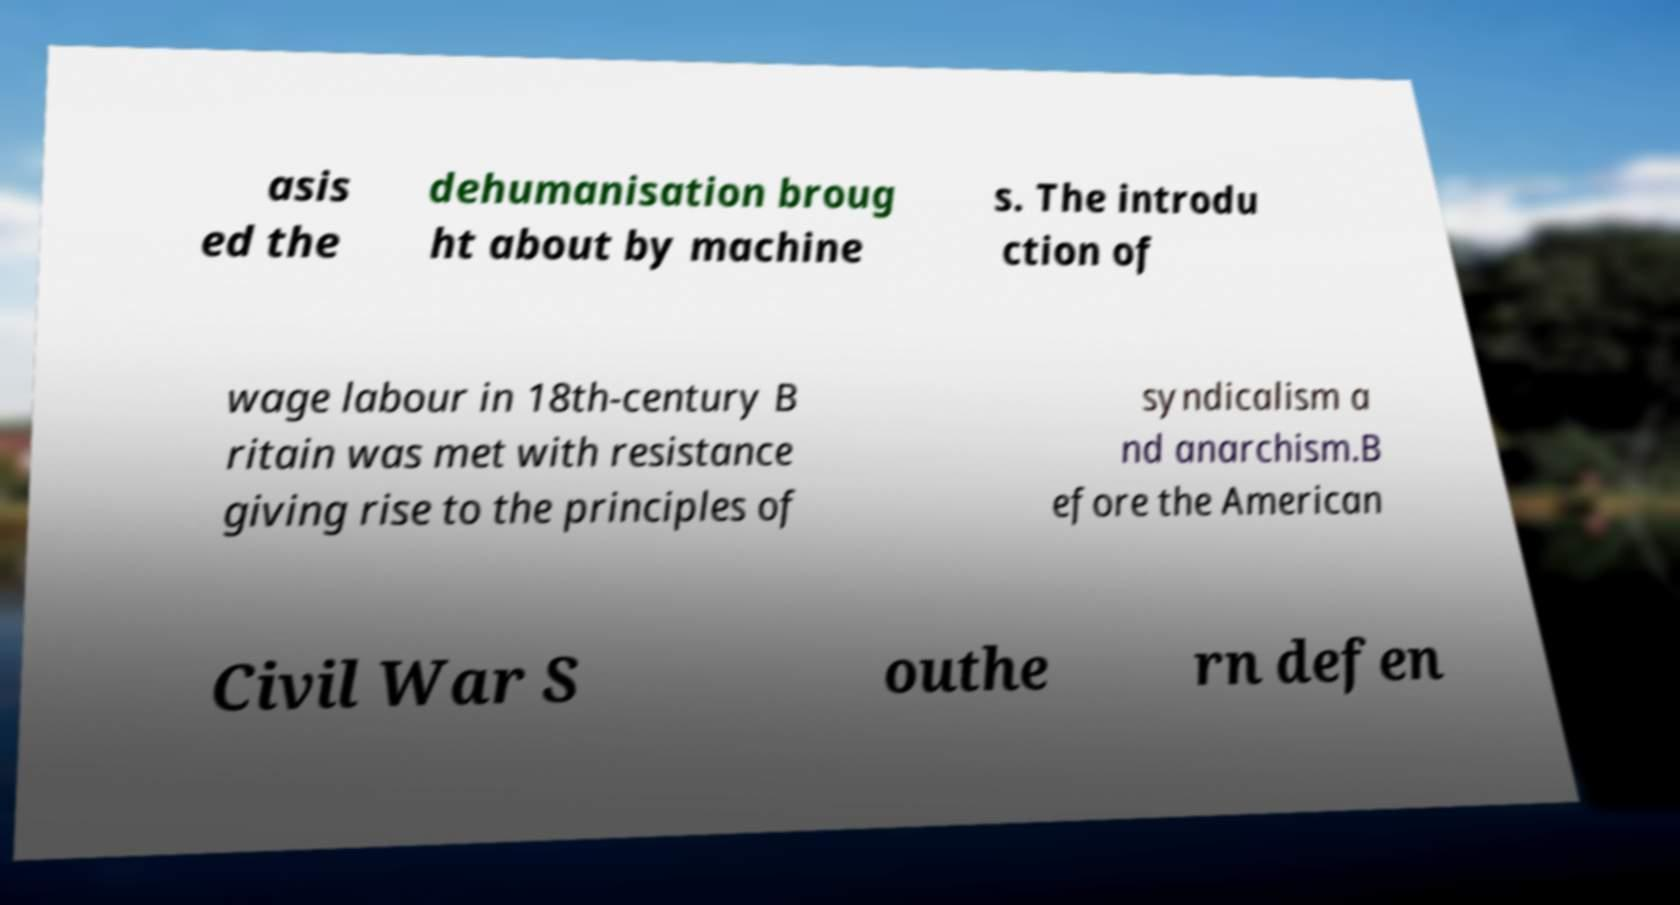Can you read and provide the text displayed in the image?This photo seems to have some interesting text. Can you extract and type it out for me? asis ed the dehumanisation broug ht about by machine s. The introdu ction of wage labour in 18th-century B ritain was met with resistance giving rise to the principles of syndicalism a nd anarchism.B efore the American Civil War S outhe rn defen 